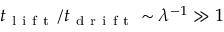<formula> <loc_0><loc_0><loc_500><loc_500>t _ { l i f t } / t _ { d r i f t } \sim \lambda ^ { - 1 } \gg 1</formula> 